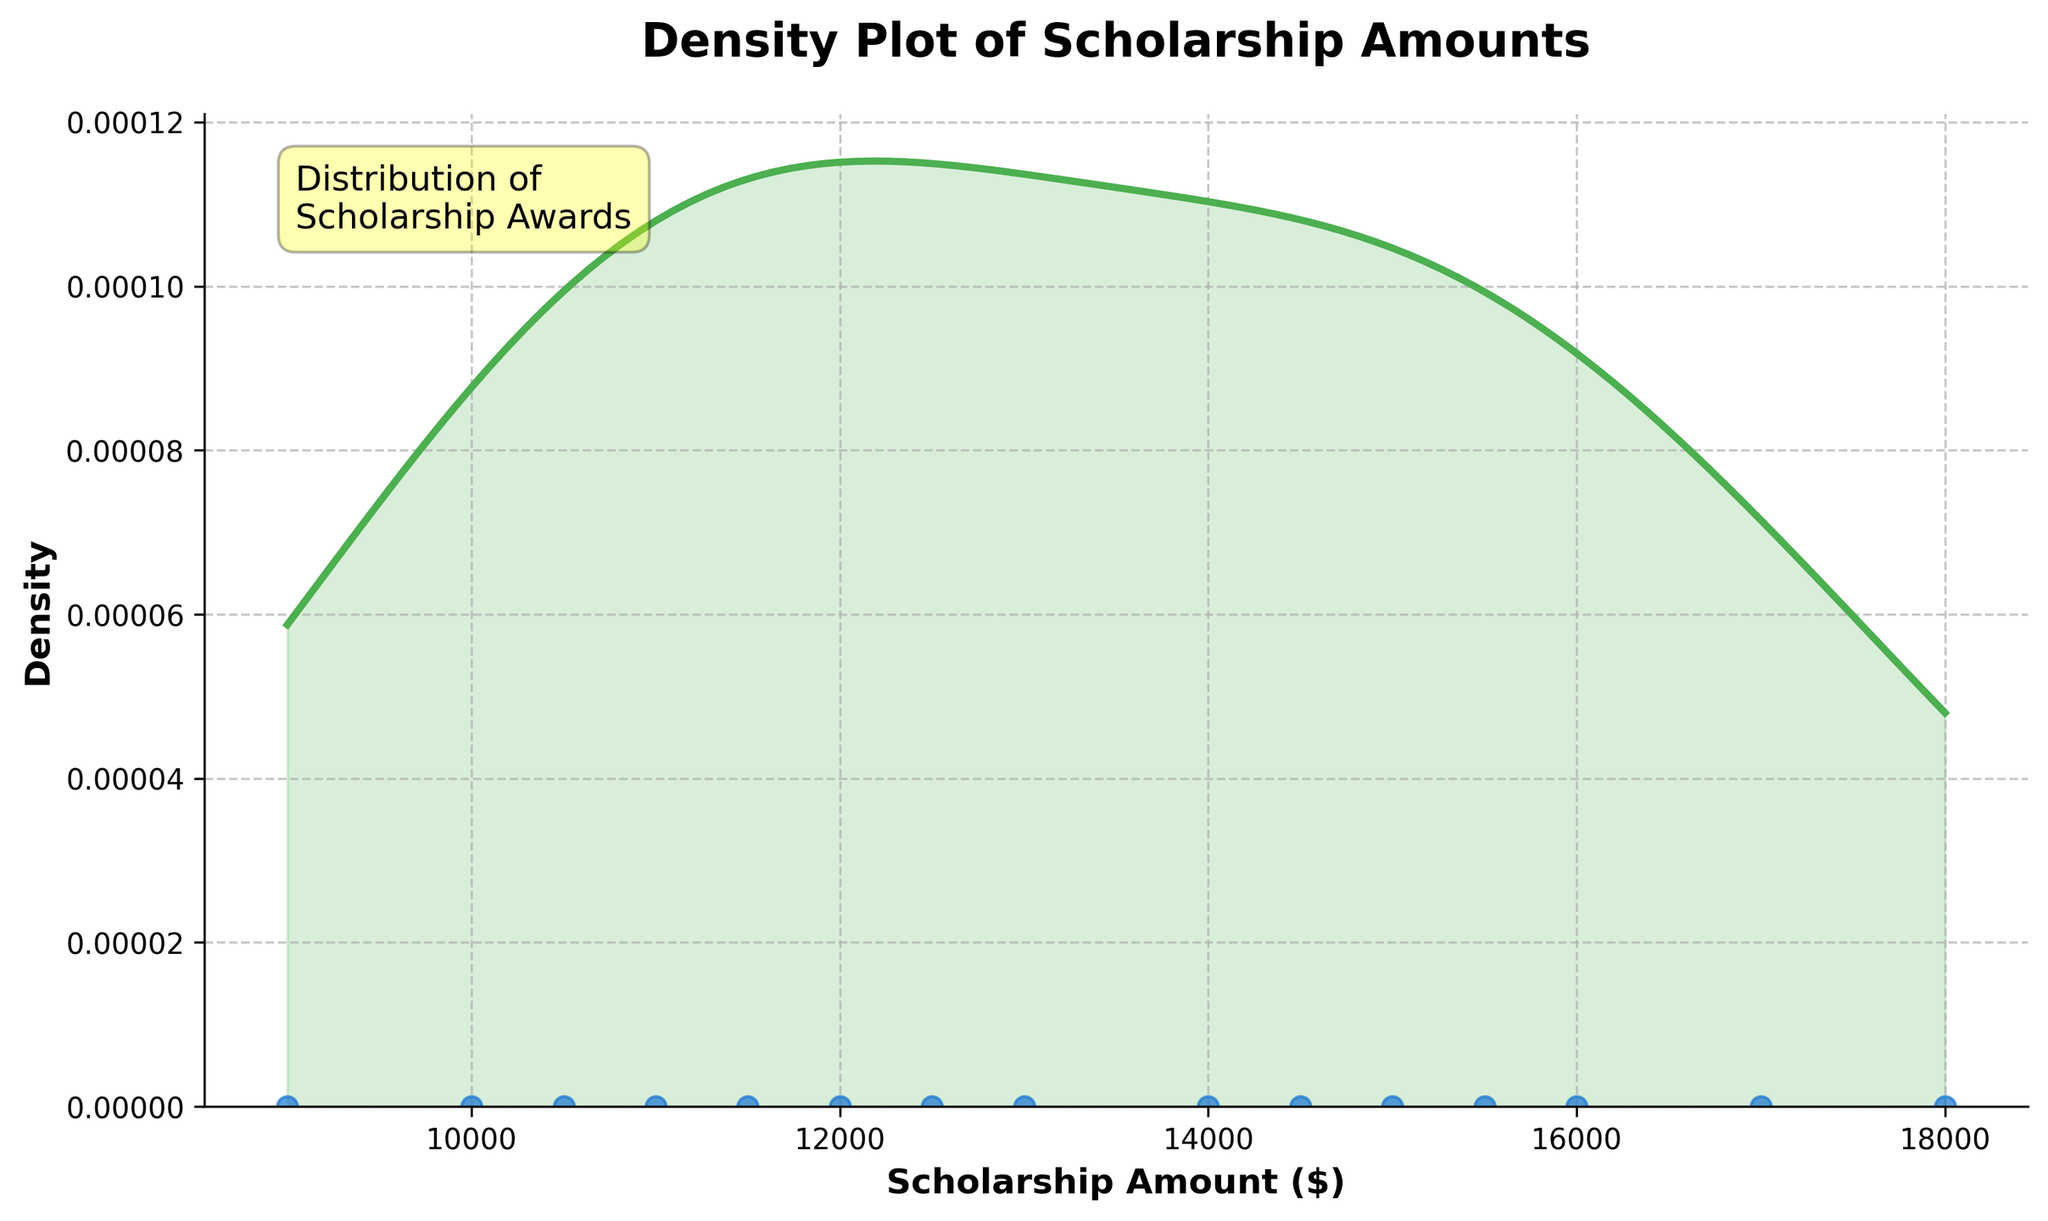What is the title of the plot? The title is usually displayed at the top of the plot. In this case, it states the main topic of the figure.
Answer: Density Plot of Scholarship Amounts How many data points are used in the density plot? The data points are represented by individual scatter points at the bottom of the plot. Count these points to determine the total number.
Answer: 15 What is the highest scholarship amount shown? Look at the x-axis range to find the maximum value shown in the plot.
Answer: $18000 What's the range of scholarship amounts shown in the plot? Identify the minimum and maximum values on the x-axis to determine the range. The smallest value is $9000 and the largest value is $18000.
Answer: $9000 to $18000 What does the shaded area under the curve represent? The shaded area under the curve represents the density of the data points, showing where scholarship amounts are more or less concentrated.
Answer: Density Where is the highest density of scholarship amounts? Look for the peaks of the density curve, which indicate the areas with the highest concentration of data points.
Answer: Around $12000 to $16000 Is there any scholarship amount with noticeably fewer data points? Check for areas on the x-axis where the density curve is relatively flat or low.
Answer: Yes, around $9000 Which scholarship amount range has the highest density? Identify the range on the x-axis with the highest peak in the density curve.
Answer: $12000 to $16000 How can you tell where the most common scholarship amounts are on the density plot? The most common scholarship amounts are indicated by the peaks in the density curve, where the curve rises highest.
Answer: Peaks in the curve How does the scholarship amount distribution visually appear? Consider the overall shape of the density curve to describe the distribution of scholarship amounts.
Answer: Normally distributed with peaks around $12000 to $16000 